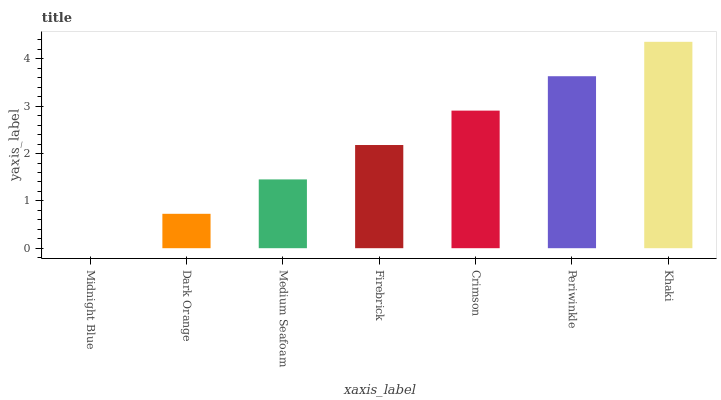Is Midnight Blue the minimum?
Answer yes or no. Yes. Is Khaki the maximum?
Answer yes or no. Yes. Is Dark Orange the minimum?
Answer yes or no. No. Is Dark Orange the maximum?
Answer yes or no. No. Is Dark Orange greater than Midnight Blue?
Answer yes or no. Yes. Is Midnight Blue less than Dark Orange?
Answer yes or no. Yes. Is Midnight Blue greater than Dark Orange?
Answer yes or no. No. Is Dark Orange less than Midnight Blue?
Answer yes or no. No. Is Firebrick the high median?
Answer yes or no. Yes. Is Firebrick the low median?
Answer yes or no. Yes. Is Midnight Blue the high median?
Answer yes or no. No. Is Midnight Blue the low median?
Answer yes or no. No. 